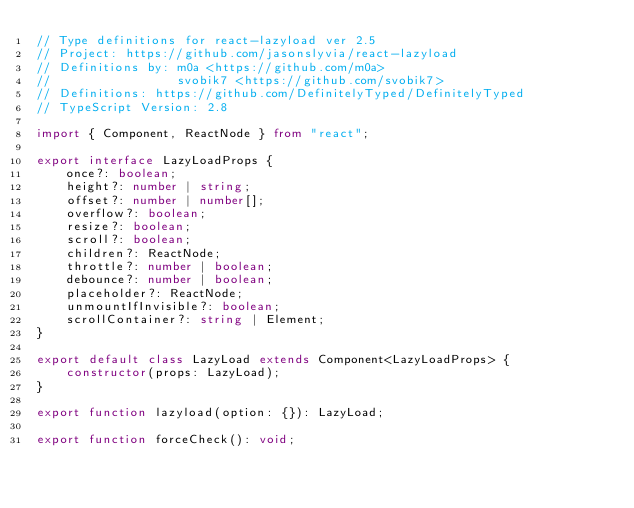<code> <loc_0><loc_0><loc_500><loc_500><_TypeScript_>// Type definitions for react-lazyload ver 2.5
// Project: https://github.com/jasonslyvia/react-lazyload
// Definitions by: m0a <https://github.com/m0a>
//                 svobik7 <https://github.com/svobik7>
// Definitions: https://github.com/DefinitelyTyped/DefinitelyTyped
// TypeScript Version: 2.8

import { Component, ReactNode } from "react";

export interface LazyLoadProps {
    once?: boolean;
    height?: number | string;
    offset?: number | number[];
    overflow?: boolean;
    resize?: boolean;
    scroll?: boolean;
    children?: ReactNode;
    throttle?: number | boolean;
    debounce?: number | boolean;
    placeholder?: ReactNode;
    unmountIfInvisible?: boolean;
    scrollContainer?: string | Element;
}

export default class LazyLoad extends Component<LazyLoadProps> {
    constructor(props: LazyLoad);
}

export function lazyload(option: {}): LazyLoad;

export function forceCheck(): void;
</code> 